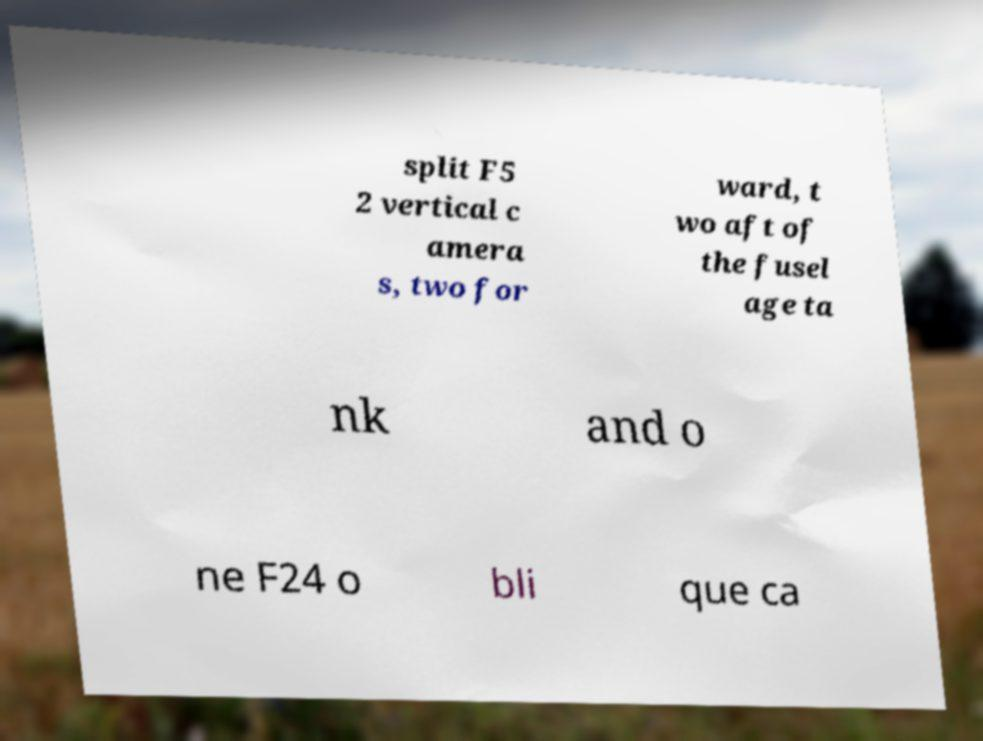Can you read and provide the text displayed in the image?This photo seems to have some interesting text. Can you extract and type it out for me? split F5 2 vertical c amera s, two for ward, t wo aft of the fusel age ta nk and o ne F24 o bli que ca 